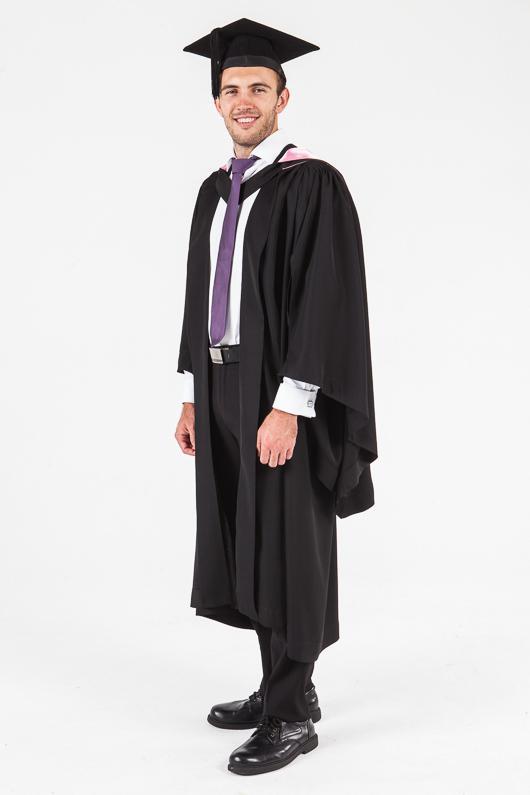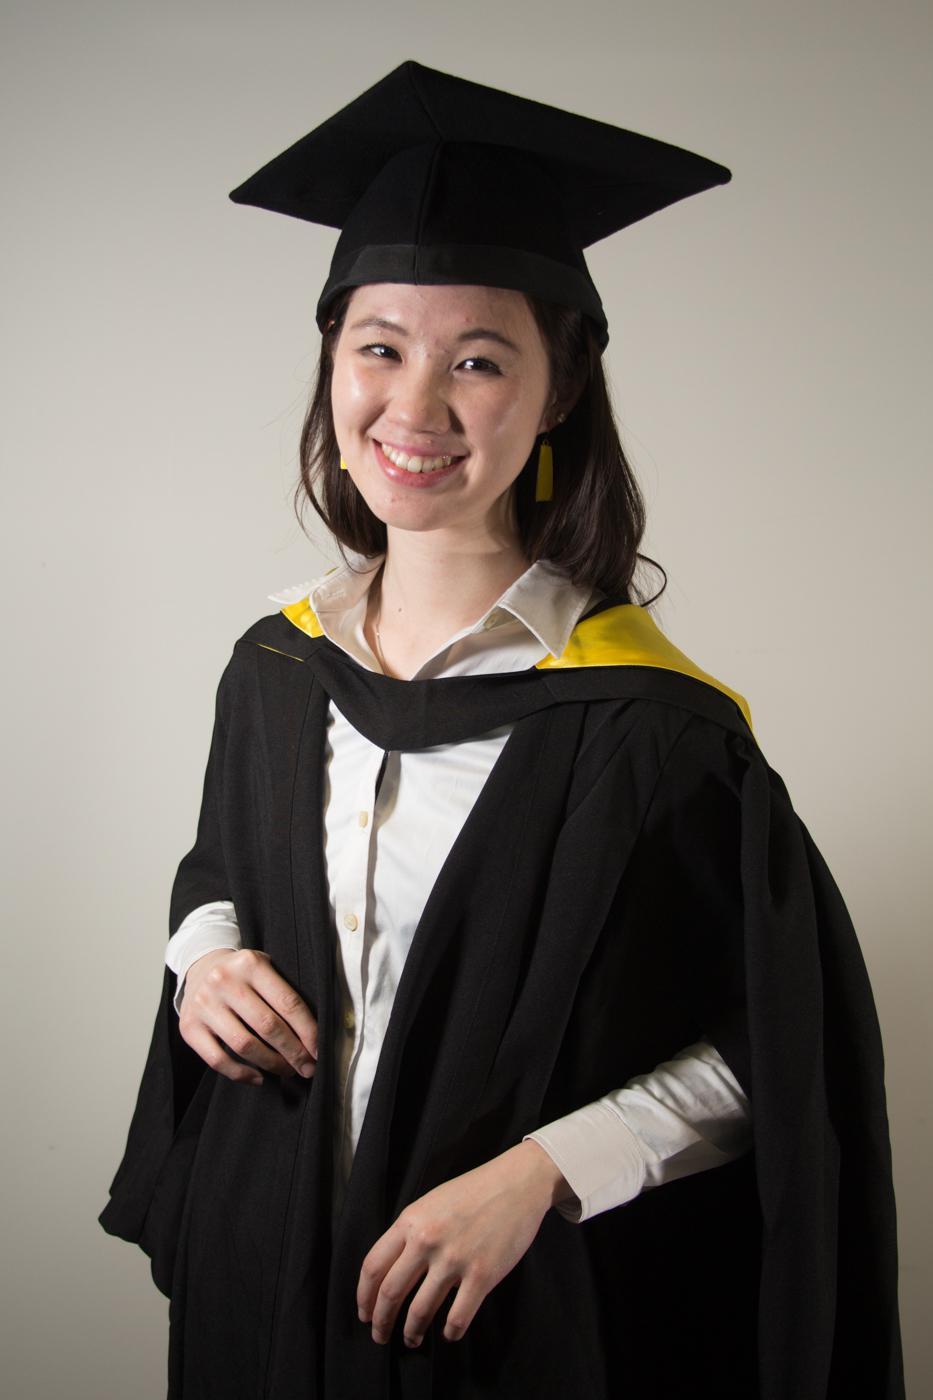The first image is the image on the left, the second image is the image on the right. For the images shown, is this caption "Both people are wearing some bright red." true? Answer yes or no. No. The first image is the image on the left, the second image is the image on the right. Examine the images to the left and right. Is the description "The graduate models on the right and left wear black robes with neck sashes and each wears something red." accurate? Answer yes or no. No. 